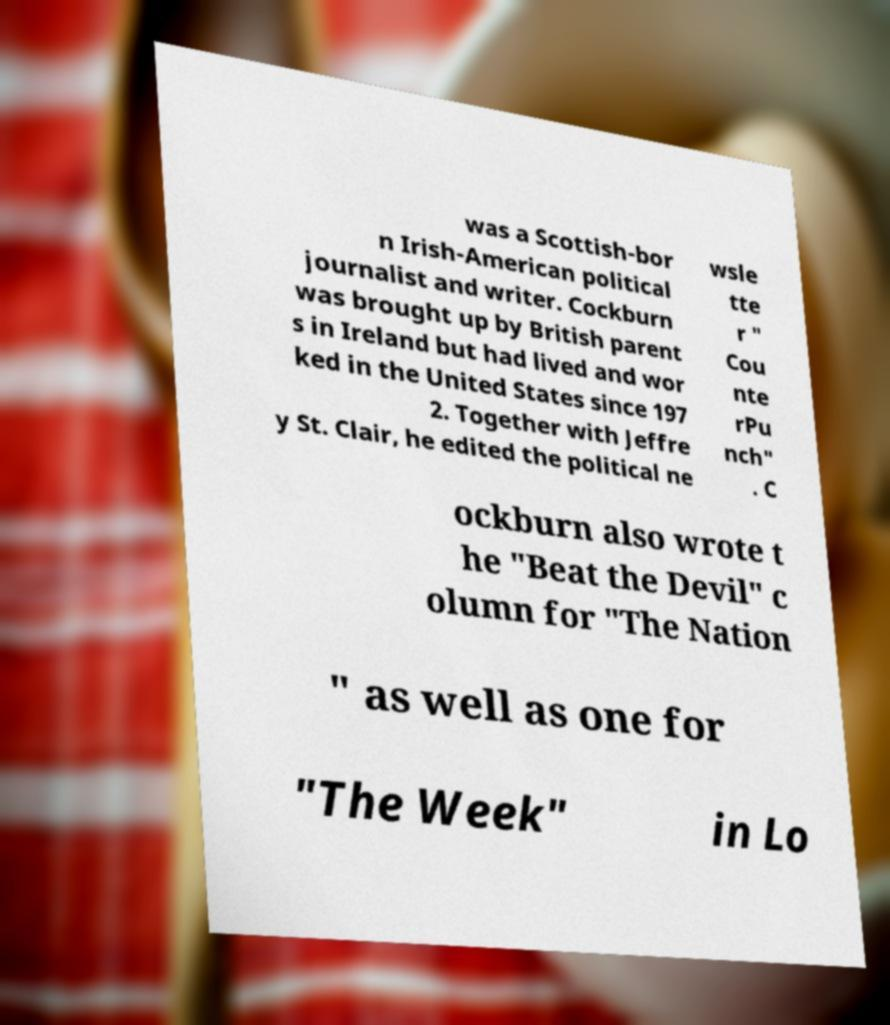Can you accurately transcribe the text from the provided image for me? was a Scottish-bor n Irish-American political journalist and writer. Cockburn was brought up by British parent s in Ireland but had lived and wor ked in the United States since 197 2. Together with Jeffre y St. Clair, he edited the political ne wsle tte r " Cou nte rPu nch" . C ockburn also wrote t he "Beat the Devil" c olumn for "The Nation " as well as one for "The Week" in Lo 